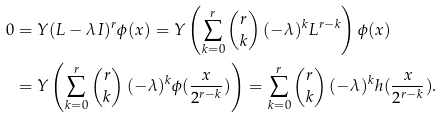Convert formula to latex. <formula><loc_0><loc_0><loc_500><loc_500>0 & = Y ( L - \lambda I ) ^ { r } \phi ( x ) = Y \left ( \sum _ { k = 0 } ^ { r } \begin{pmatrix} r \\ k \end{pmatrix} ( - \lambda ) ^ { k } L ^ { r - k } \right ) \phi ( x ) \\ & = Y \left ( \sum _ { k = 0 } ^ { r } \begin{pmatrix} r \\ k \end{pmatrix} ( - \lambda ) ^ { k } \phi ( \frac { x } { 2 ^ { r - k } } ) \right ) = \sum _ { k = 0 } ^ { r } \begin{pmatrix} r \\ k \end{pmatrix} ( - \lambda ) ^ { k } h ( \frac { x } { 2 ^ { r - k } } ) .</formula> 